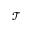Convert formula to latex. <formula><loc_0><loc_0><loc_500><loc_500>\mathcal { T }</formula> 